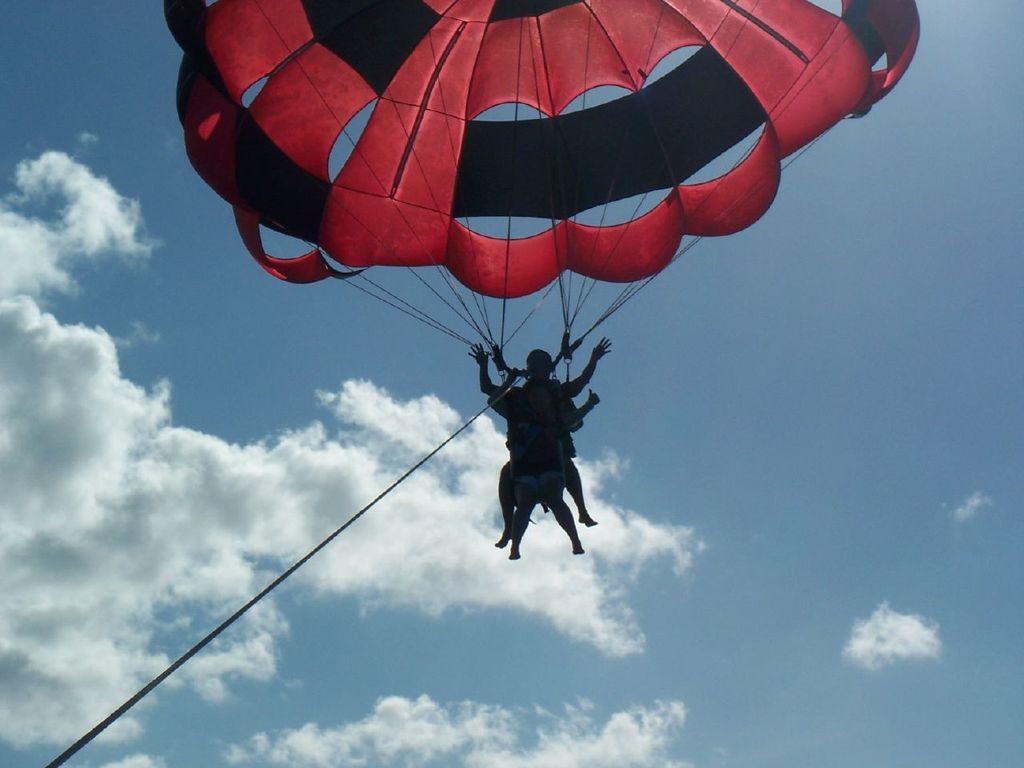In one or two sentences, can you explain what this image depicts? In this image we can see two people paragliding. We can also see the ropes and the sky which looks cloudy. 